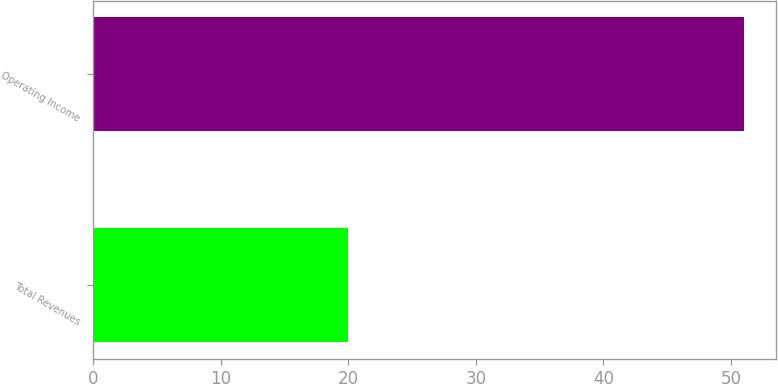Convert chart to OTSL. <chart><loc_0><loc_0><loc_500><loc_500><bar_chart><fcel>Total Revenues<fcel>Operating Income<nl><fcel>20<fcel>51<nl></chart> 